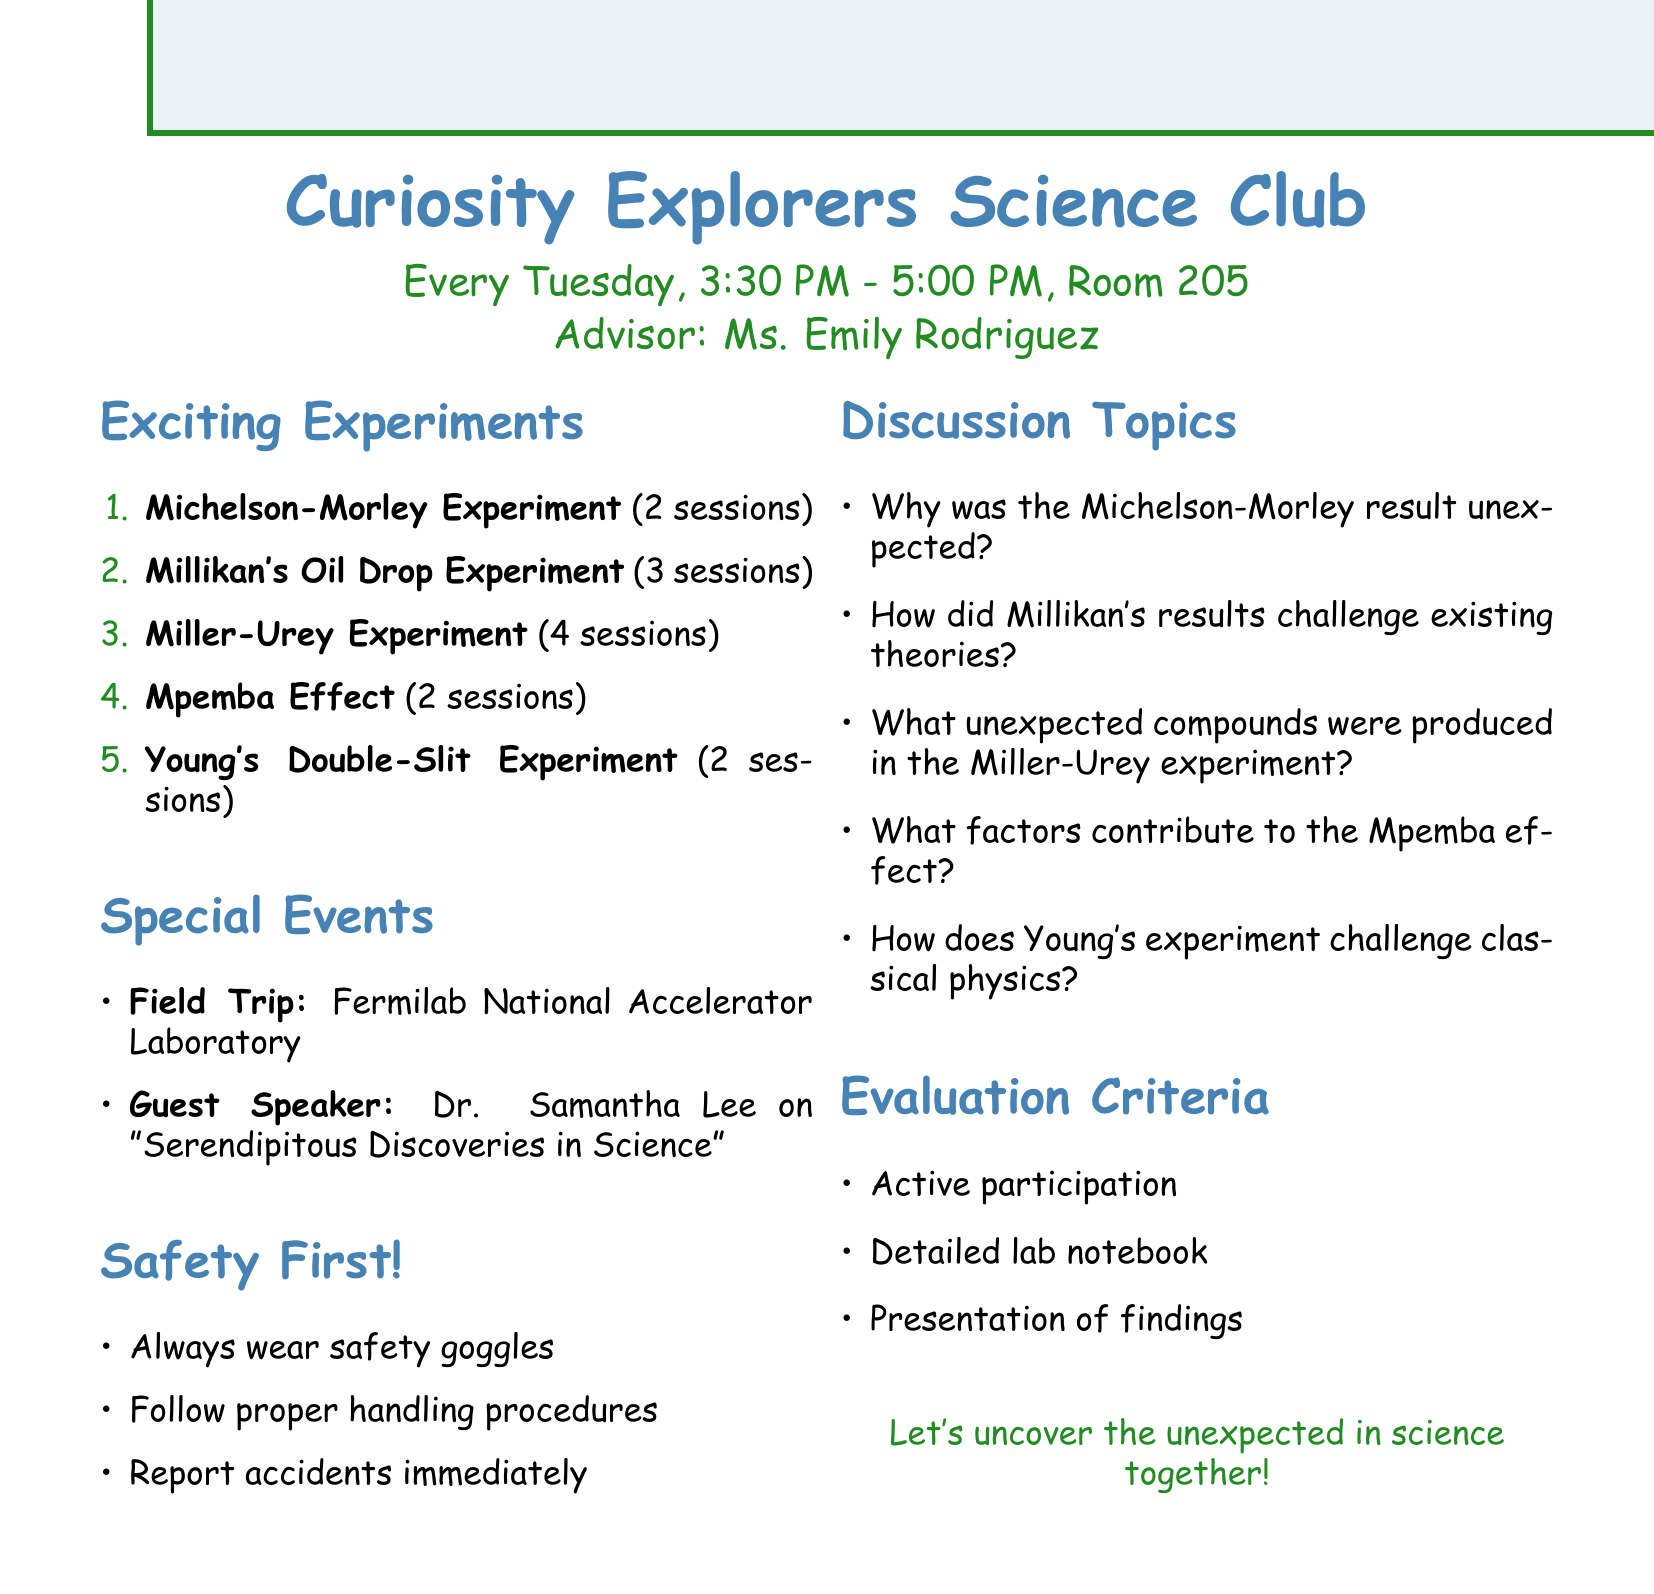What is the name of the club? The name of the club is explicitly stated in the document, which is the "Curiosity Explorers Science Club."
Answer: Curiosity Explorers Science Club When does the club meet? The meeting schedule is provided in the document, stating that meetings occur "Every Tuesday, 3:30 PM - 5:00 PM."
Answer: Every Tuesday, 3:30 PM - 5:00 PM Who is the advisor of the club? The document lists Ms. Emily Rodriguez as the advisor for the club.
Answer: Ms. Emily Rodriguez What is the first experiment to be conducted? The agenda lists the Michelson-Morley Experiment as the first experiment.
Answer: Michelson-Morley Experiment How many sessions are expected for the Miller-Urey Experiment? The document specifies that the Miller-Urey Experiment is expected to take 4 sessions.
Answer: 4 sessions What is the topic of the guest speaker session? The document states that Dr. Samantha Lee will speak on "Serendipitous Discoveries in Science."
Answer: Serendipitous Discoveries in Science What safety guideline is mentioned for the experiments? The document provides a clear safety guideline to always wear safety goggles during experiments.
Answer: Always wear safety goggles What is one expected discussion point for the Mpemba Effect? The document notes that one discussion point for the Mpemba Effect is "What factors might contribute to this counterintuitive effect?"
Answer: What factors might contribute to this counterintuitive effect? What is the purpose of the field trip? The document outlines that the purpose of the field trip is to observe modern particle physics experiments.
Answer: Observing modern particle physics experiments 